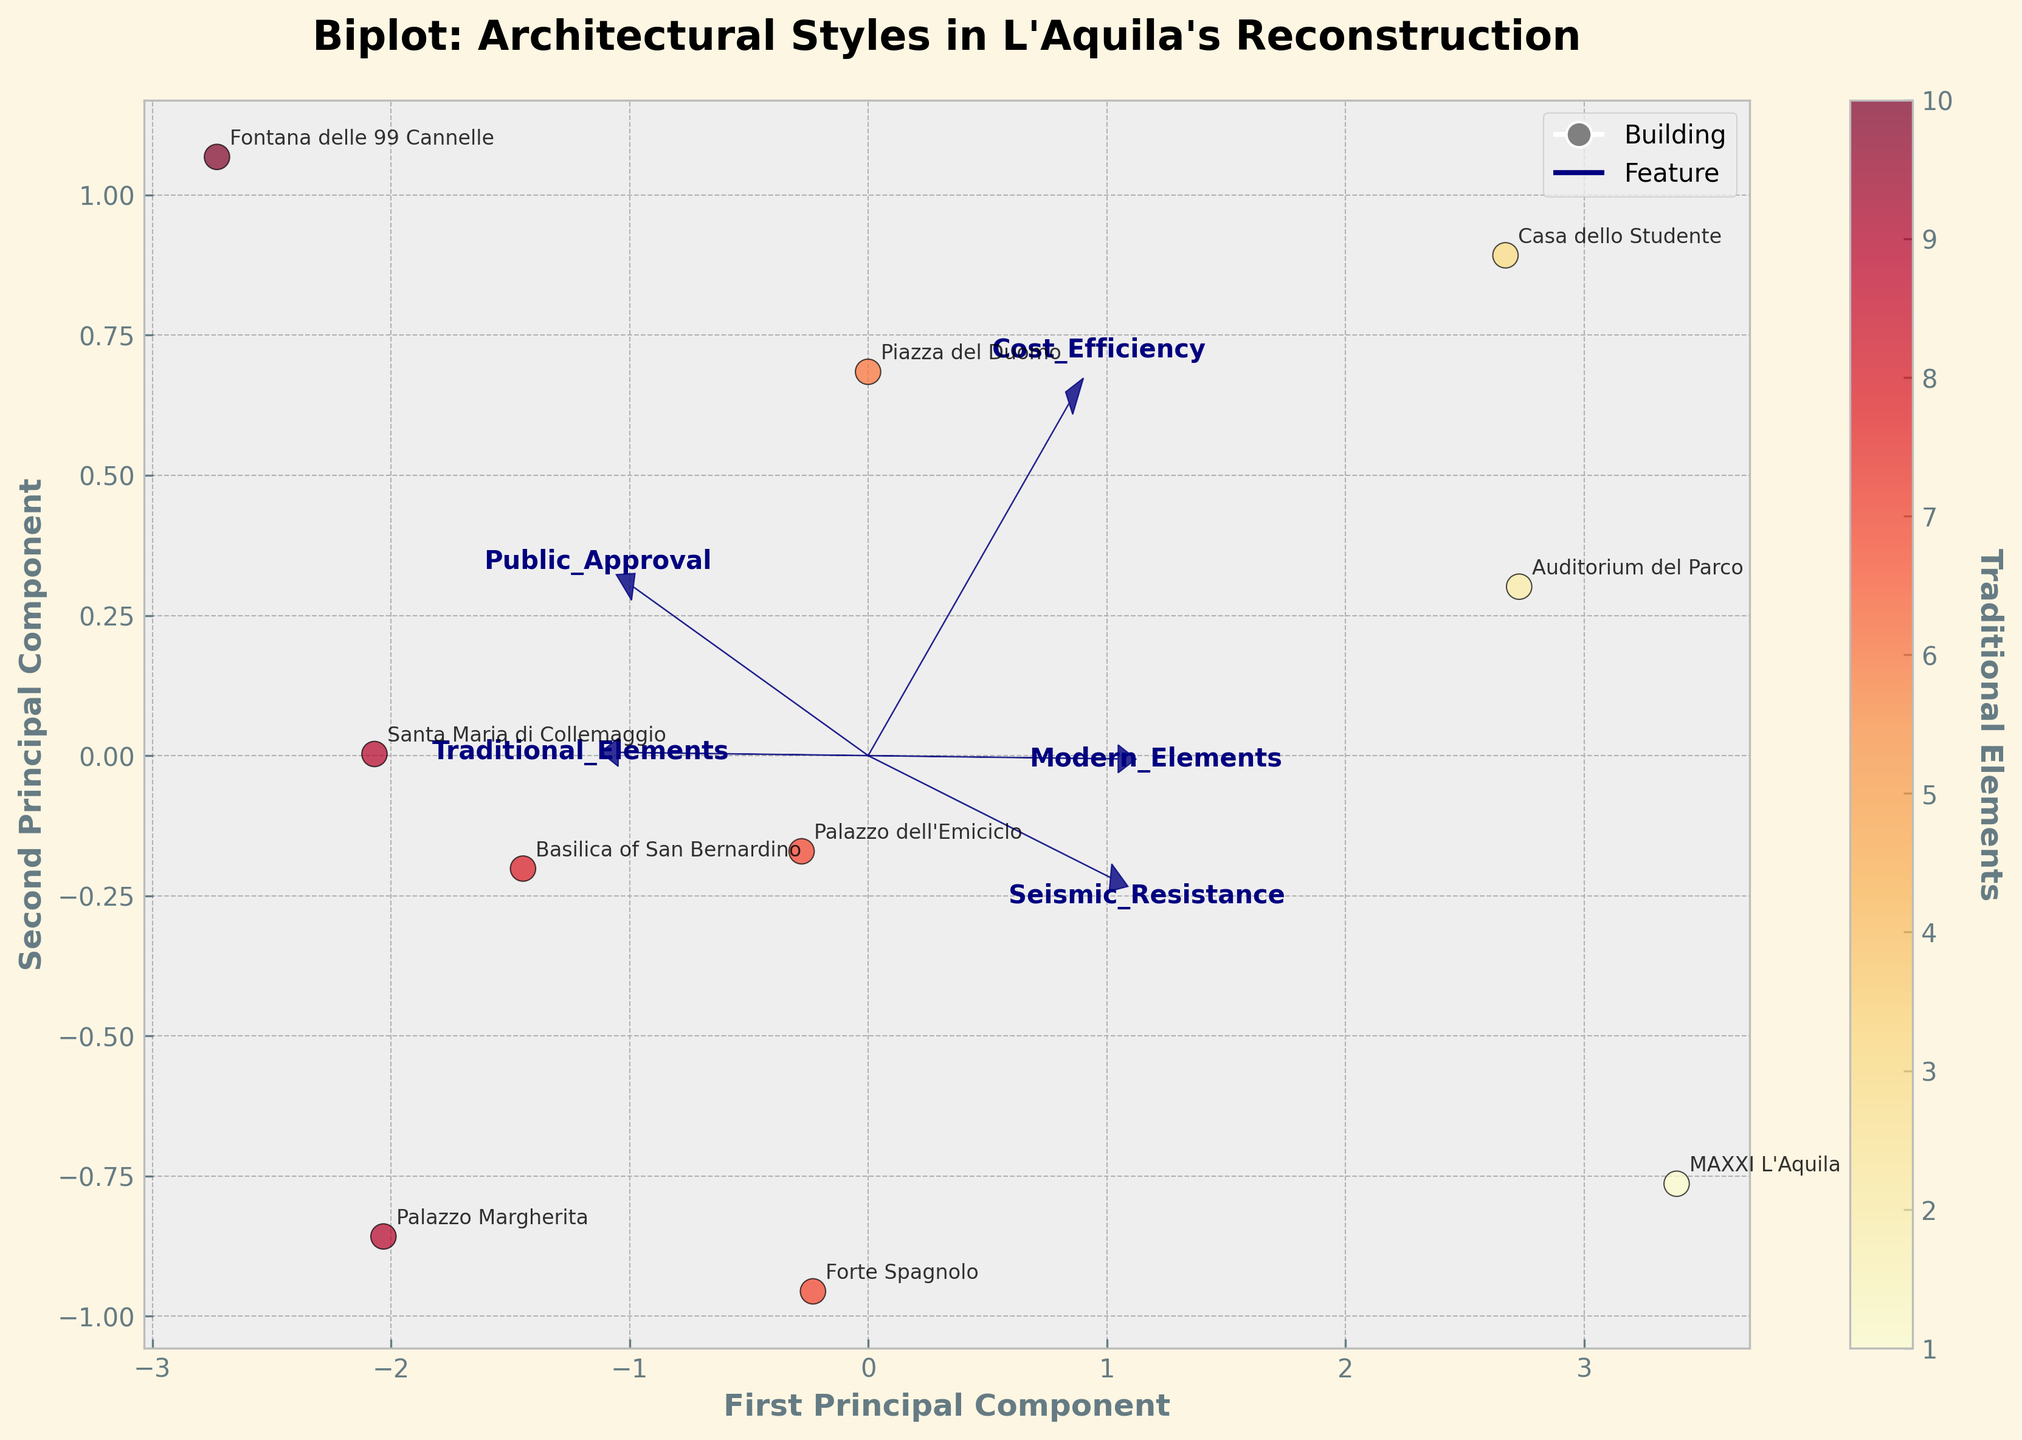What is the title of the biplot? The title of the plot is typically located at the top center of the figure and is displayed in bold font for emphasis. In this case, it would be prominently shown and read directly from the top.
Answer: Biplot: Architectural Styles in L'Aquila's Reconstruction How many data points are represented in the biplot? By counting the number of distinct labeled points (associated with different buildings) shown on the scatter plot, you can determine the number of data points.
Answer: 10 Which building has the highest number of traditional elements? Look at the color gradient of the points; the building with the darkest shade (closer to red) represents the highest number of traditional elements. Verify by checking the point label.
Answer: Fontana delle 99 Cannelle Which feature has the largest arrow, indicating the most significant influence on the principal components? Compare the lengths of all the arrows originating from the origin (0,0). The longest arrow indicates the most significant feature.
Answer: Seismic Resistance Which buildings are closest on the first principal component but furthest on the second? Trace the positions of the data points along the first axis (horizontal) where they have similar values, then check their separation along the second axis (vertical).
Answer: Basilica of San Bernardino and Forte Spagnolo Considering both seismic resistance and public approval, which building scores high in both? Identify the direction of the arrows for seismic resistance and public approval. Find the point aligned in both directions, implying high scores for these features.
Answer: Casa dello Studente How are traditional elements and modern elements related based on their arrows' directions? Observe the angles between the arrows for traditional elements and modern elements. If arrows are close to 180 degrees apart, they are negatively correlated.
Answer: Negatively correlated Which building shows the highest cost efficiency and modern elements combined? Locate the building positioned most closely aligned with the directions of the arrows for cost efficiency and modern elements, indicating high values in both.
Answer: Casa dello Studente Do modern buildings generally have higher cost efficiency than traditional ones based on the plot? Check the placement of buildings labeled with high modern elements against the cost efficiency arrow direction. Observe if most are positioned positively along the cost efficiency direction.
Answer: Yes 